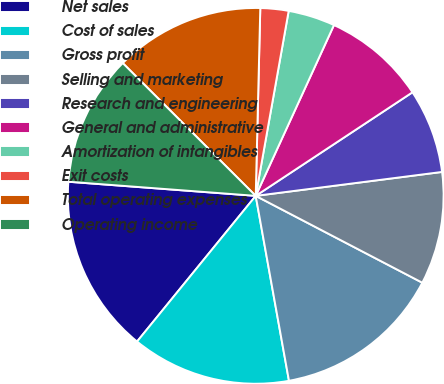Convert chart. <chart><loc_0><loc_0><loc_500><loc_500><pie_chart><fcel>Net sales<fcel>Cost of sales<fcel>Gross profit<fcel>Selling and marketing<fcel>Research and engineering<fcel>General and administrative<fcel>Amortization of intangibles<fcel>Exit costs<fcel>Total operating expenses<fcel>Operating income<nl><fcel>15.32%<fcel>13.71%<fcel>14.52%<fcel>9.68%<fcel>7.26%<fcel>8.87%<fcel>4.03%<fcel>2.42%<fcel>12.9%<fcel>11.29%<nl></chart> 